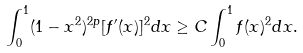<formula> <loc_0><loc_0><loc_500><loc_500>\int _ { 0 } ^ { 1 } ( 1 - x ^ { 2 } ) ^ { 2 p } [ f ^ { \prime } ( x ) ] ^ { 2 } d x \geq C \int _ { 0 } ^ { 1 } f ( x ) ^ { 2 } d x .</formula> 